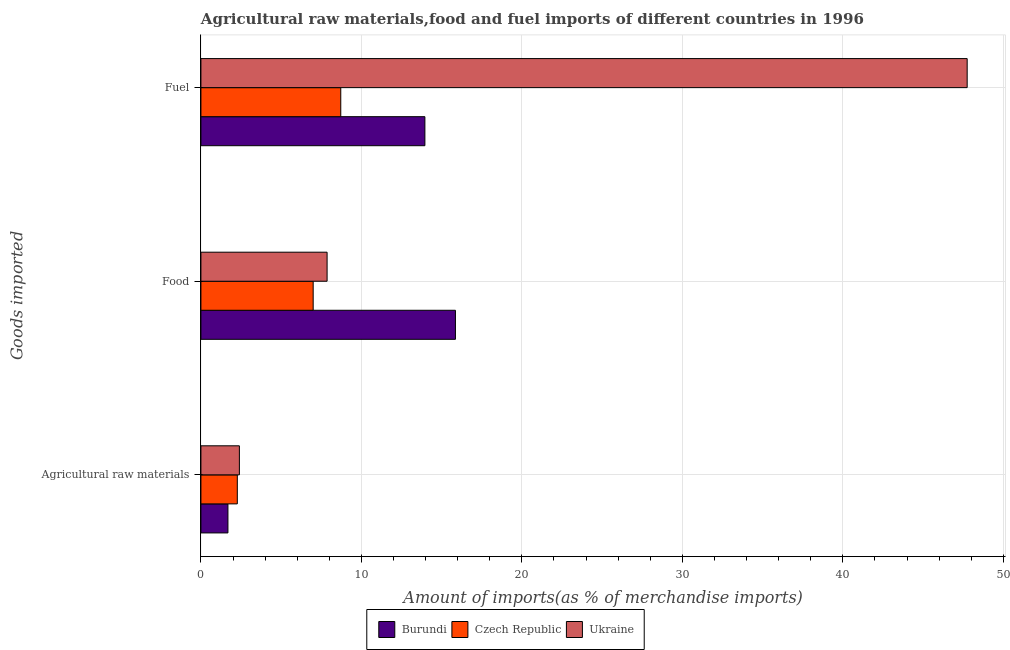How many groups of bars are there?
Your response must be concise. 3. Are the number of bars on each tick of the Y-axis equal?
Offer a very short reply. Yes. What is the label of the 2nd group of bars from the top?
Keep it short and to the point. Food. What is the percentage of food imports in Ukraine?
Ensure brevity in your answer.  7.86. Across all countries, what is the maximum percentage of fuel imports?
Keep it short and to the point. 47.75. Across all countries, what is the minimum percentage of fuel imports?
Give a very brief answer. 8.71. In which country was the percentage of food imports maximum?
Offer a very short reply. Burundi. In which country was the percentage of fuel imports minimum?
Your answer should be very brief. Czech Republic. What is the total percentage of food imports in the graph?
Make the answer very short. 30.72. What is the difference between the percentage of food imports in Ukraine and that in Burundi?
Provide a succinct answer. -8. What is the difference between the percentage of food imports in Burundi and the percentage of raw materials imports in Ukraine?
Your response must be concise. 13.46. What is the average percentage of raw materials imports per country?
Give a very brief answer. 2.12. What is the difference between the percentage of fuel imports and percentage of food imports in Czech Republic?
Your answer should be compact. 1.72. In how many countries, is the percentage of raw materials imports greater than 4 %?
Make the answer very short. 0. What is the ratio of the percentage of food imports in Ukraine to that in Burundi?
Make the answer very short. 0.5. What is the difference between the highest and the second highest percentage of food imports?
Give a very brief answer. 8. What is the difference between the highest and the lowest percentage of raw materials imports?
Your answer should be compact. 0.71. In how many countries, is the percentage of raw materials imports greater than the average percentage of raw materials imports taken over all countries?
Your response must be concise. 2. Is the sum of the percentage of raw materials imports in Burundi and Ukraine greater than the maximum percentage of food imports across all countries?
Provide a succinct answer. No. What does the 2nd bar from the top in Food represents?
Your answer should be compact. Czech Republic. What does the 3rd bar from the bottom in Food represents?
Offer a very short reply. Ukraine. How many bars are there?
Your answer should be compact. 9. How many countries are there in the graph?
Your answer should be compact. 3. What is the difference between two consecutive major ticks on the X-axis?
Ensure brevity in your answer.  10. Are the values on the major ticks of X-axis written in scientific E-notation?
Ensure brevity in your answer.  No. Does the graph contain grids?
Offer a terse response. Yes. How many legend labels are there?
Make the answer very short. 3. What is the title of the graph?
Keep it short and to the point. Agricultural raw materials,food and fuel imports of different countries in 1996. Does "Guyana" appear as one of the legend labels in the graph?
Your answer should be very brief. No. What is the label or title of the X-axis?
Ensure brevity in your answer.  Amount of imports(as % of merchandise imports). What is the label or title of the Y-axis?
Keep it short and to the point. Goods imported. What is the Amount of imports(as % of merchandise imports) in Burundi in Agricultural raw materials?
Ensure brevity in your answer.  1.68. What is the Amount of imports(as % of merchandise imports) of Czech Republic in Agricultural raw materials?
Provide a short and direct response. 2.27. What is the Amount of imports(as % of merchandise imports) of Ukraine in Agricultural raw materials?
Provide a succinct answer. 2.4. What is the Amount of imports(as % of merchandise imports) in Burundi in Food?
Your answer should be compact. 15.86. What is the Amount of imports(as % of merchandise imports) in Czech Republic in Food?
Your response must be concise. 6.99. What is the Amount of imports(as % of merchandise imports) in Ukraine in Food?
Keep it short and to the point. 7.86. What is the Amount of imports(as % of merchandise imports) of Burundi in Fuel?
Make the answer very short. 13.96. What is the Amount of imports(as % of merchandise imports) in Czech Republic in Fuel?
Provide a succinct answer. 8.71. What is the Amount of imports(as % of merchandise imports) of Ukraine in Fuel?
Your response must be concise. 47.75. Across all Goods imported, what is the maximum Amount of imports(as % of merchandise imports) of Burundi?
Your answer should be compact. 15.86. Across all Goods imported, what is the maximum Amount of imports(as % of merchandise imports) in Czech Republic?
Keep it short and to the point. 8.71. Across all Goods imported, what is the maximum Amount of imports(as % of merchandise imports) in Ukraine?
Offer a terse response. 47.75. Across all Goods imported, what is the minimum Amount of imports(as % of merchandise imports) of Burundi?
Your response must be concise. 1.68. Across all Goods imported, what is the minimum Amount of imports(as % of merchandise imports) of Czech Republic?
Provide a short and direct response. 2.27. Across all Goods imported, what is the minimum Amount of imports(as % of merchandise imports) in Ukraine?
Keep it short and to the point. 2.4. What is the total Amount of imports(as % of merchandise imports) of Burundi in the graph?
Provide a short and direct response. 31.5. What is the total Amount of imports(as % of merchandise imports) in Czech Republic in the graph?
Keep it short and to the point. 17.98. What is the total Amount of imports(as % of merchandise imports) in Ukraine in the graph?
Offer a very short reply. 58.01. What is the difference between the Amount of imports(as % of merchandise imports) of Burundi in Agricultural raw materials and that in Food?
Your answer should be very brief. -14.18. What is the difference between the Amount of imports(as % of merchandise imports) of Czech Republic in Agricultural raw materials and that in Food?
Your answer should be very brief. -4.73. What is the difference between the Amount of imports(as % of merchandise imports) of Ukraine in Agricultural raw materials and that in Food?
Provide a short and direct response. -5.47. What is the difference between the Amount of imports(as % of merchandise imports) of Burundi in Agricultural raw materials and that in Fuel?
Give a very brief answer. -12.27. What is the difference between the Amount of imports(as % of merchandise imports) in Czech Republic in Agricultural raw materials and that in Fuel?
Provide a succinct answer. -6.45. What is the difference between the Amount of imports(as % of merchandise imports) in Ukraine in Agricultural raw materials and that in Fuel?
Provide a short and direct response. -45.35. What is the difference between the Amount of imports(as % of merchandise imports) of Burundi in Food and that in Fuel?
Make the answer very short. 1.9. What is the difference between the Amount of imports(as % of merchandise imports) in Czech Republic in Food and that in Fuel?
Your answer should be compact. -1.72. What is the difference between the Amount of imports(as % of merchandise imports) of Ukraine in Food and that in Fuel?
Give a very brief answer. -39.89. What is the difference between the Amount of imports(as % of merchandise imports) in Burundi in Agricultural raw materials and the Amount of imports(as % of merchandise imports) in Czech Republic in Food?
Provide a succinct answer. -5.31. What is the difference between the Amount of imports(as % of merchandise imports) in Burundi in Agricultural raw materials and the Amount of imports(as % of merchandise imports) in Ukraine in Food?
Offer a very short reply. -6.18. What is the difference between the Amount of imports(as % of merchandise imports) of Czech Republic in Agricultural raw materials and the Amount of imports(as % of merchandise imports) of Ukraine in Food?
Provide a short and direct response. -5.6. What is the difference between the Amount of imports(as % of merchandise imports) of Burundi in Agricultural raw materials and the Amount of imports(as % of merchandise imports) of Czech Republic in Fuel?
Provide a succinct answer. -7.03. What is the difference between the Amount of imports(as % of merchandise imports) in Burundi in Agricultural raw materials and the Amount of imports(as % of merchandise imports) in Ukraine in Fuel?
Offer a terse response. -46.06. What is the difference between the Amount of imports(as % of merchandise imports) in Czech Republic in Agricultural raw materials and the Amount of imports(as % of merchandise imports) in Ukraine in Fuel?
Offer a very short reply. -45.48. What is the difference between the Amount of imports(as % of merchandise imports) of Burundi in Food and the Amount of imports(as % of merchandise imports) of Czech Republic in Fuel?
Provide a short and direct response. 7.15. What is the difference between the Amount of imports(as % of merchandise imports) of Burundi in Food and the Amount of imports(as % of merchandise imports) of Ukraine in Fuel?
Offer a very short reply. -31.89. What is the difference between the Amount of imports(as % of merchandise imports) of Czech Republic in Food and the Amount of imports(as % of merchandise imports) of Ukraine in Fuel?
Make the answer very short. -40.75. What is the average Amount of imports(as % of merchandise imports) in Burundi per Goods imported?
Your answer should be compact. 10.5. What is the average Amount of imports(as % of merchandise imports) in Czech Republic per Goods imported?
Offer a terse response. 5.99. What is the average Amount of imports(as % of merchandise imports) in Ukraine per Goods imported?
Make the answer very short. 19.34. What is the difference between the Amount of imports(as % of merchandise imports) of Burundi and Amount of imports(as % of merchandise imports) of Czech Republic in Agricultural raw materials?
Give a very brief answer. -0.58. What is the difference between the Amount of imports(as % of merchandise imports) of Burundi and Amount of imports(as % of merchandise imports) of Ukraine in Agricultural raw materials?
Your response must be concise. -0.71. What is the difference between the Amount of imports(as % of merchandise imports) of Czech Republic and Amount of imports(as % of merchandise imports) of Ukraine in Agricultural raw materials?
Your answer should be very brief. -0.13. What is the difference between the Amount of imports(as % of merchandise imports) in Burundi and Amount of imports(as % of merchandise imports) in Czech Republic in Food?
Give a very brief answer. 8.86. What is the difference between the Amount of imports(as % of merchandise imports) of Burundi and Amount of imports(as % of merchandise imports) of Ukraine in Food?
Your answer should be compact. 8. What is the difference between the Amount of imports(as % of merchandise imports) of Czech Republic and Amount of imports(as % of merchandise imports) of Ukraine in Food?
Keep it short and to the point. -0.87. What is the difference between the Amount of imports(as % of merchandise imports) of Burundi and Amount of imports(as % of merchandise imports) of Czech Republic in Fuel?
Provide a short and direct response. 5.24. What is the difference between the Amount of imports(as % of merchandise imports) of Burundi and Amount of imports(as % of merchandise imports) of Ukraine in Fuel?
Offer a very short reply. -33.79. What is the difference between the Amount of imports(as % of merchandise imports) of Czech Republic and Amount of imports(as % of merchandise imports) of Ukraine in Fuel?
Offer a very short reply. -39.03. What is the ratio of the Amount of imports(as % of merchandise imports) in Burundi in Agricultural raw materials to that in Food?
Offer a very short reply. 0.11. What is the ratio of the Amount of imports(as % of merchandise imports) of Czech Republic in Agricultural raw materials to that in Food?
Give a very brief answer. 0.32. What is the ratio of the Amount of imports(as % of merchandise imports) of Ukraine in Agricultural raw materials to that in Food?
Your answer should be compact. 0.3. What is the ratio of the Amount of imports(as % of merchandise imports) in Burundi in Agricultural raw materials to that in Fuel?
Offer a terse response. 0.12. What is the ratio of the Amount of imports(as % of merchandise imports) in Czech Republic in Agricultural raw materials to that in Fuel?
Give a very brief answer. 0.26. What is the ratio of the Amount of imports(as % of merchandise imports) of Ukraine in Agricultural raw materials to that in Fuel?
Make the answer very short. 0.05. What is the ratio of the Amount of imports(as % of merchandise imports) of Burundi in Food to that in Fuel?
Give a very brief answer. 1.14. What is the ratio of the Amount of imports(as % of merchandise imports) in Czech Republic in Food to that in Fuel?
Your response must be concise. 0.8. What is the ratio of the Amount of imports(as % of merchandise imports) in Ukraine in Food to that in Fuel?
Your answer should be very brief. 0.16. What is the difference between the highest and the second highest Amount of imports(as % of merchandise imports) of Burundi?
Offer a very short reply. 1.9. What is the difference between the highest and the second highest Amount of imports(as % of merchandise imports) in Czech Republic?
Offer a very short reply. 1.72. What is the difference between the highest and the second highest Amount of imports(as % of merchandise imports) in Ukraine?
Offer a terse response. 39.89. What is the difference between the highest and the lowest Amount of imports(as % of merchandise imports) of Burundi?
Provide a short and direct response. 14.18. What is the difference between the highest and the lowest Amount of imports(as % of merchandise imports) of Czech Republic?
Give a very brief answer. 6.45. What is the difference between the highest and the lowest Amount of imports(as % of merchandise imports) in Ukraine?
Ensure brevity in your answer.  45.35. 